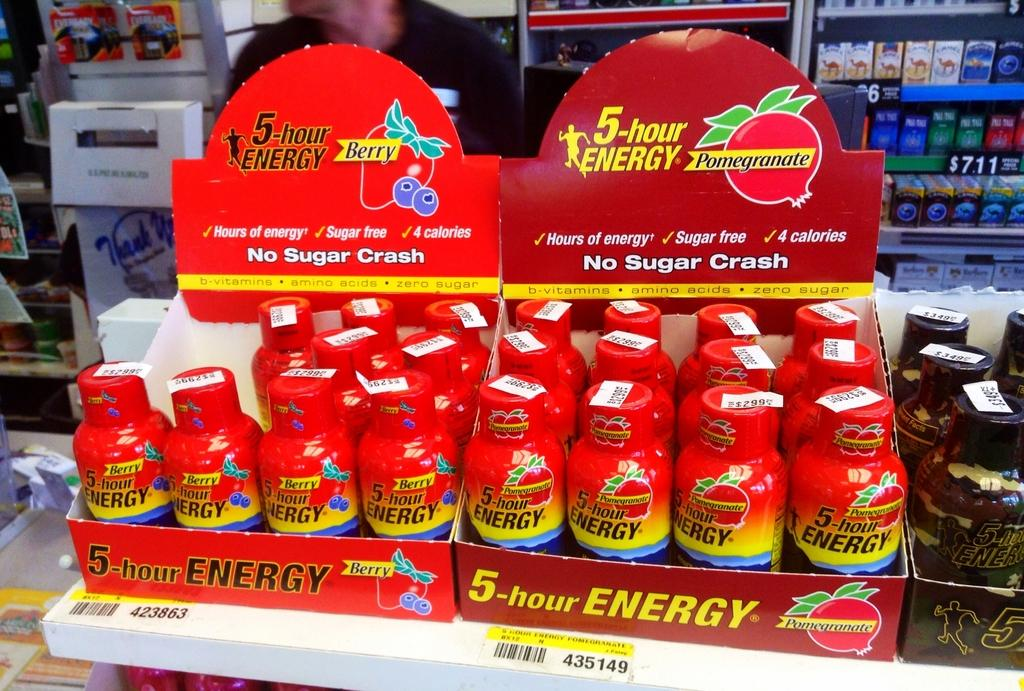Provide a one-sentence caption for the provided image. store display of 4-hour energy, one carton berry flavor, the other pomegranate. 